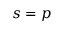<formula> <loc_0><loc_0><loc_500><loc_500>s = p</formula> 